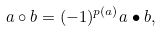<formula> <loc_0><loc_0><loc_500><loc_500>a \circ b = ( - 1 ) ^ { p ( a ) } a \bullet b ,</formula> 